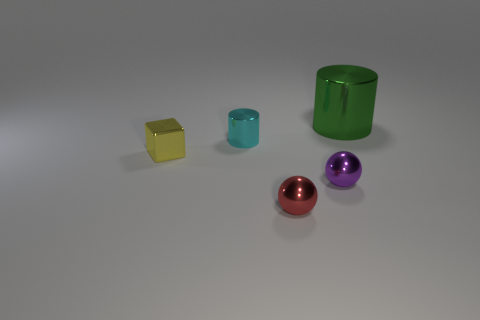What number of other objects are there of the same size as the purple object?
Your response must be concise. 3. Is there anything else that has the same shape as the tiny yellow thing?
Offer a terse response. No. Are there the same number of blocks that are to the right of the small cyan metal object and big brown blocks?
Keep it short and to the point. Yes. How many tiny yellow objects have the same material as the small purple thing?
Keep it short and to the point. 1. There is a large cylinder that is the same material as the small cylinder; what is its color?
Offer a terse response. Green. Do the small cyan object and the tiny yellow shiny thing have the same shape?
Keep it short and to the point. No. Are there any shiny things that are to the left of the cylinder that is in front of the cylinder on the right side of the small red metallic ball?
Offer a terse response. Yes. The red metal object that is the same size as the purple ball is what shape?
Your response must be concise. Sphere. There is a small yellow shiny object; are there any small purple shiny objects in front of it?
Give a very brief answer. Yes. Is the size of the cyan cylinder the same as the red sphere?
Keep it short and to the point. Yes. 